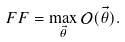Convert formula to latex. <formula><loc_0><loc_0><loc_500><loc_500>F F = \max _ { \vec { \theta } } \mathcal { O } ( \vec { \theta } ) .</formula> 